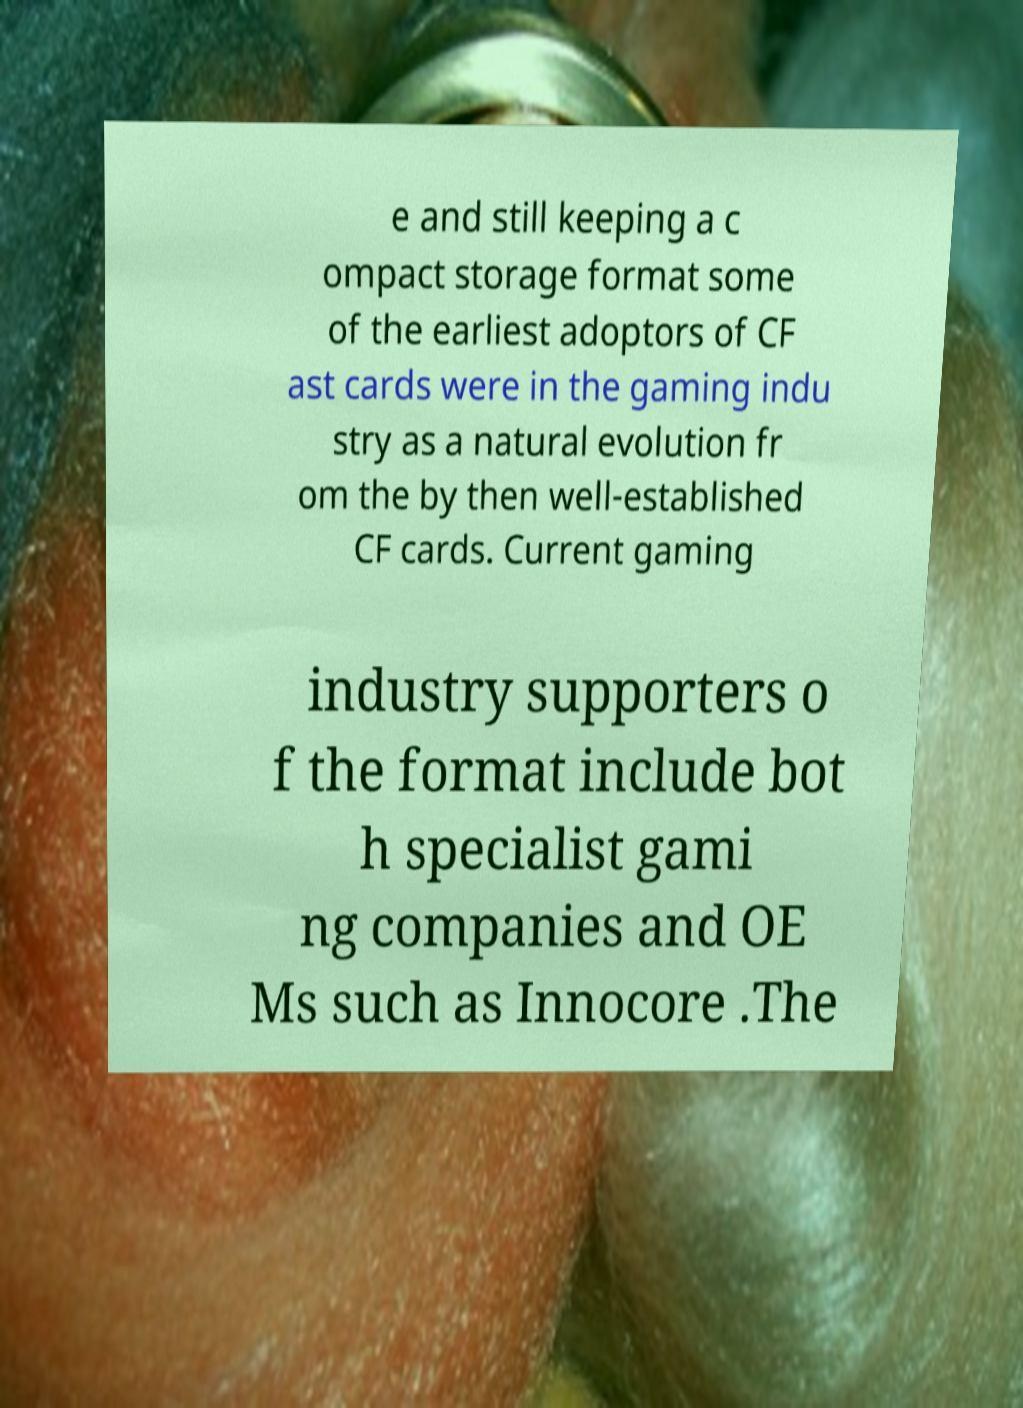Can you read and provide the text displayed in the image?This photo seems to have some interesting text. Can you extract and type it out for me? e and still keeping a c ompact storage format some of the earliest adoptors of CF ast cards were in the gaming indu stry as a natural evolution fr om the by then well-established CF cards. Current gaming industry supporters o f the format include bot h specialist gami ng companies and OE Ms such as Innocore .The 